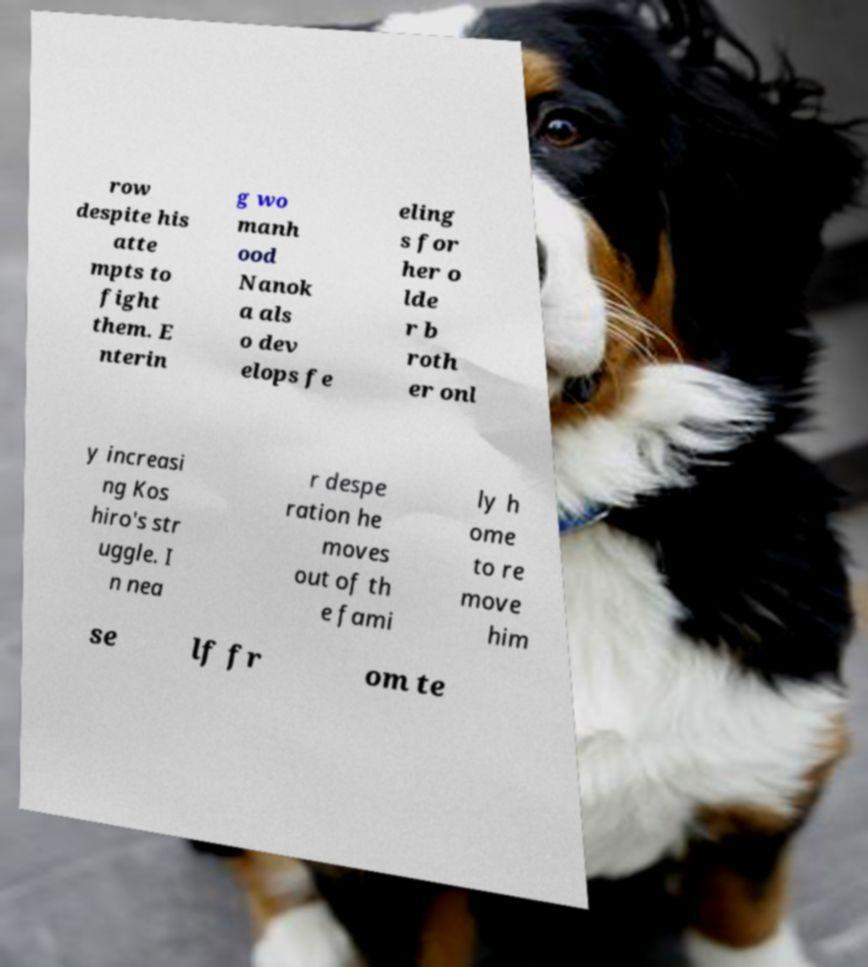Could you assist in decoding the text presented in this image and type it out clearly? row despite his atte mpts to fight them. E nterin g wo manh ood Nanok a als o dev elops fe eling s for her o lde r b roth er onl y increasi ng Kos hiro's str uggle. I n nea r despe ration he moves out of th e fami ly h ome to re move him se lf fr om te 